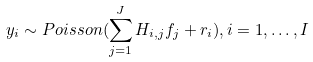<formula> <loc_0><loc_0><loc_500><loc_500>y _ { i } \sim P o i s s o n ( \sum _ { j = 1 } ^ { J } H _ { i , j } f _ { j } + r _ { i } ) , i = 1 , \dots , I</formula> 